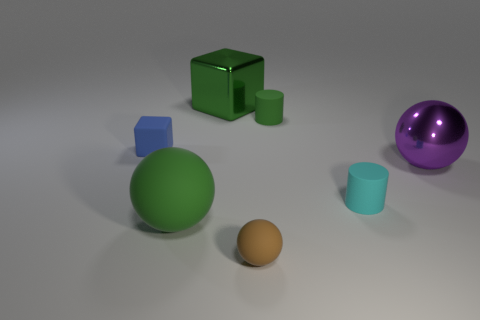Add 1 rubber objects. How many objects exist? 8 Subtract all cylinders. How many objects are left? 5 Add 7 tiny matte cylinders. How many tiny matte cylinders exist? 9 Subtract 0 brown cylinders. How many objects are left? 7 Subtract all big green spheres. Subtract all large cubes. How many objects are left? 5 Add 3 brown matte spheres. How many brown matte spheres are left? 4 